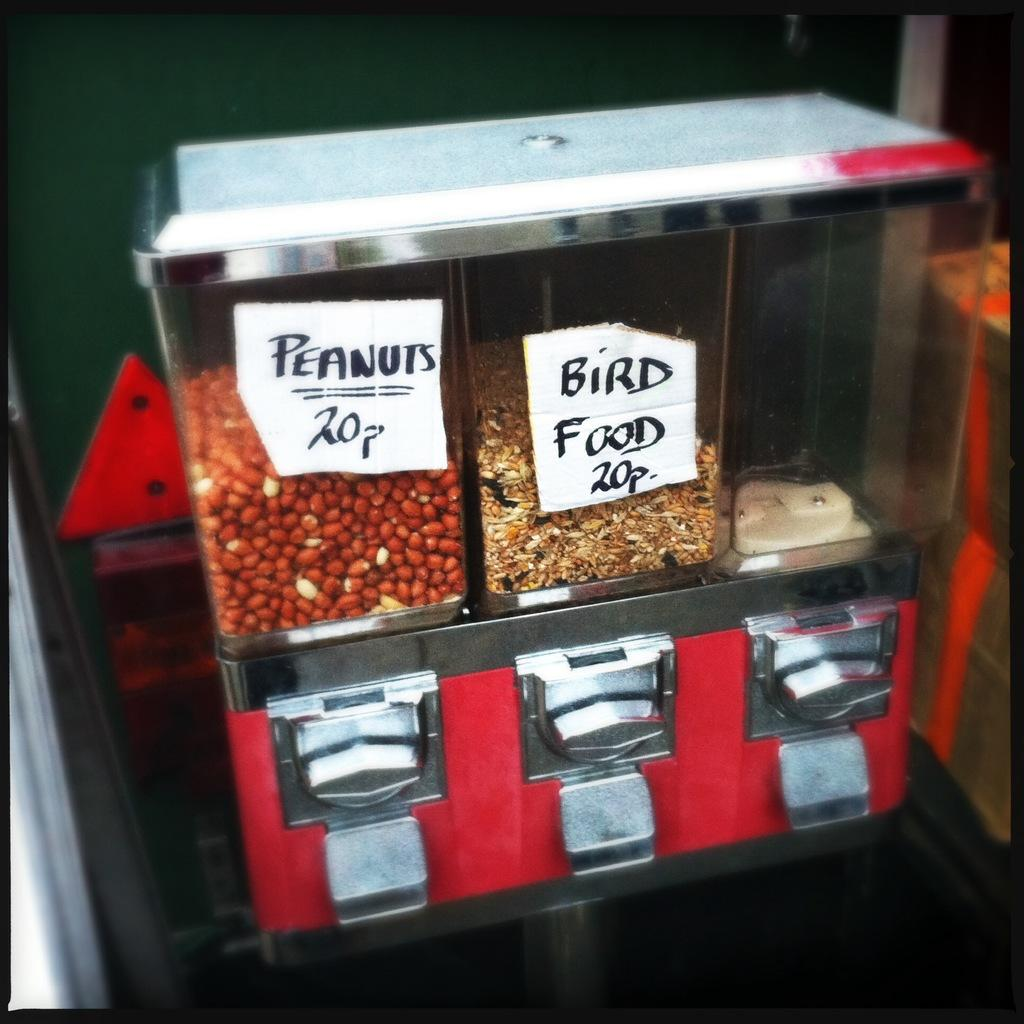What type of food is visible in the image? There are peanuts and bird food in the image. How is the bird food contained in the image? The bird food is in a glass bowl. What color is the shirt worn by the bird in the image? There is no bird or shirt present in the image; it only features peanuts and bird food in a glass bowl. 